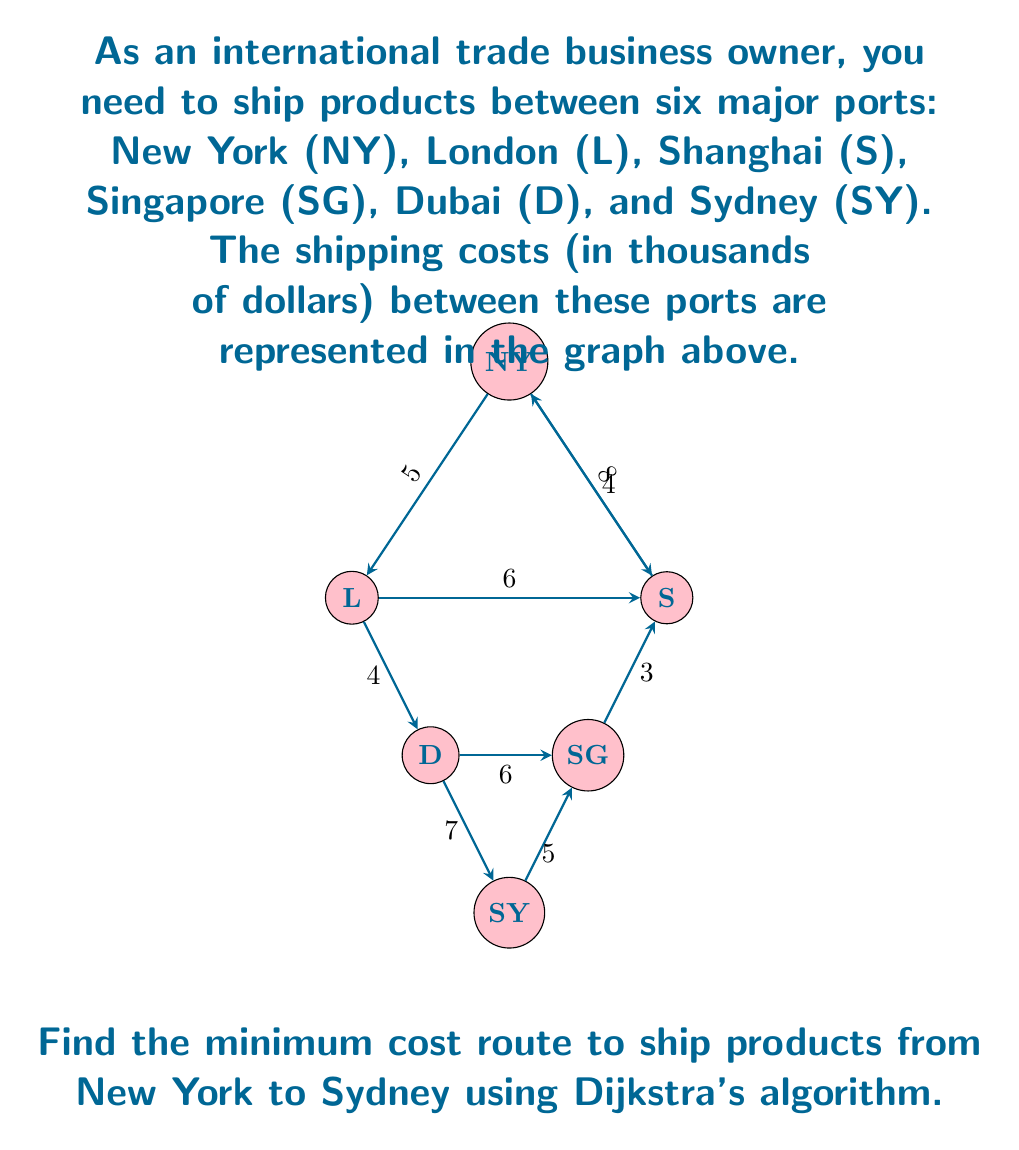What is the answer to this math problem? To solve this problem using Dijkstra's algorithm, we'll follow these steps:

1) Initialize:
   - Set distance to NY as 0, and all other nodes as infinity.
   - Set NY as the current node.
   - Mark all nodes as unvisited.

2) For the current node, consider all unvisited neighbors and calculate their tentative distances.
   - If the calculated distance is less than the previously recorded distance, update it.

3) Mark the current node as visited.

4) If the destination node (SY) has been marked visited, we're done.
   Otherwise, select the unvisited node with the smallest tentative distance and set it as the new current node. Go back to step 2.

Let's apply the algorithm:

Start: NY (0), L (∞), S (∞), SG (∞), D (∞), SY (∞)

From NY:
NY -> L: 5, NY -> S: 8
Updated: NY (0), L (5), S (8), SG (∞), D (∞), SY (∞)
Mark NY as visited.

From L (smallest unvisited):
L -> D: 5 + 4 = 9
Updated: NY (0), L (5), S (8), SG (∞), D (9), SY (∞)
Mark L as visited.

From S:
S -> SG: 8 + 3 = 11, S -> NY: 8 + 4 = 12 (no update)
Updated: NY (0), L (5), S (8), SG (11), D (9), SY (∞)
Mark S as visited.

From D:
D -> SY: 9 + 7 = 16, D -> SG: 9 + 6 = 15
Updated: NY (0), L (5), S (8), SG (11), D (9), SY (16)
Mark D as visited.

From SG:
SG -> SY: 11 + 5 = 16 (no update)
Mark SG as visited.

SY is the only unvisited node left, so we're done.

The minimum cost route is: NY -> L -> D -> SY, with a total cost of 16.
Answer: NY -> L -> D -> SY, cost = $16,000 